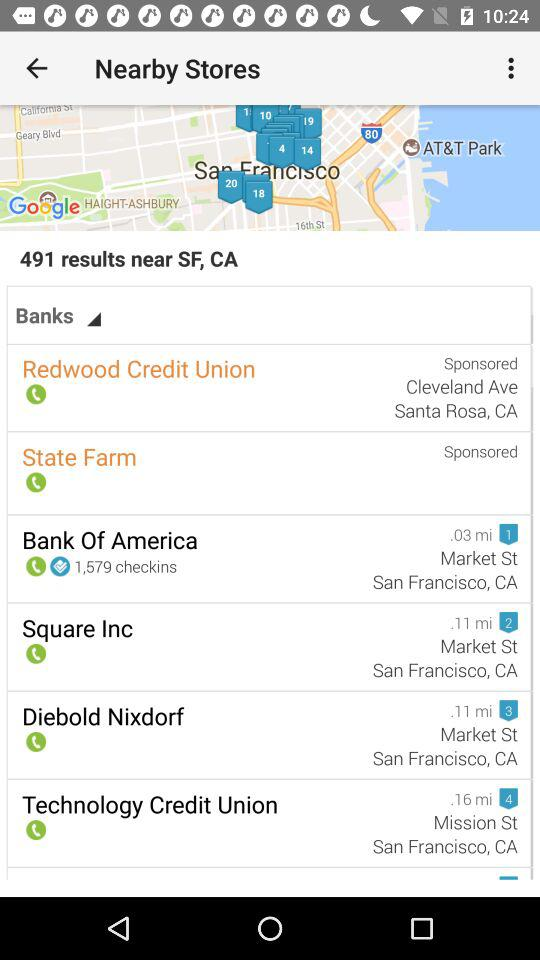What store is 0.16 miles away? The store that is 16 miles away is "Technology Credit Union". 